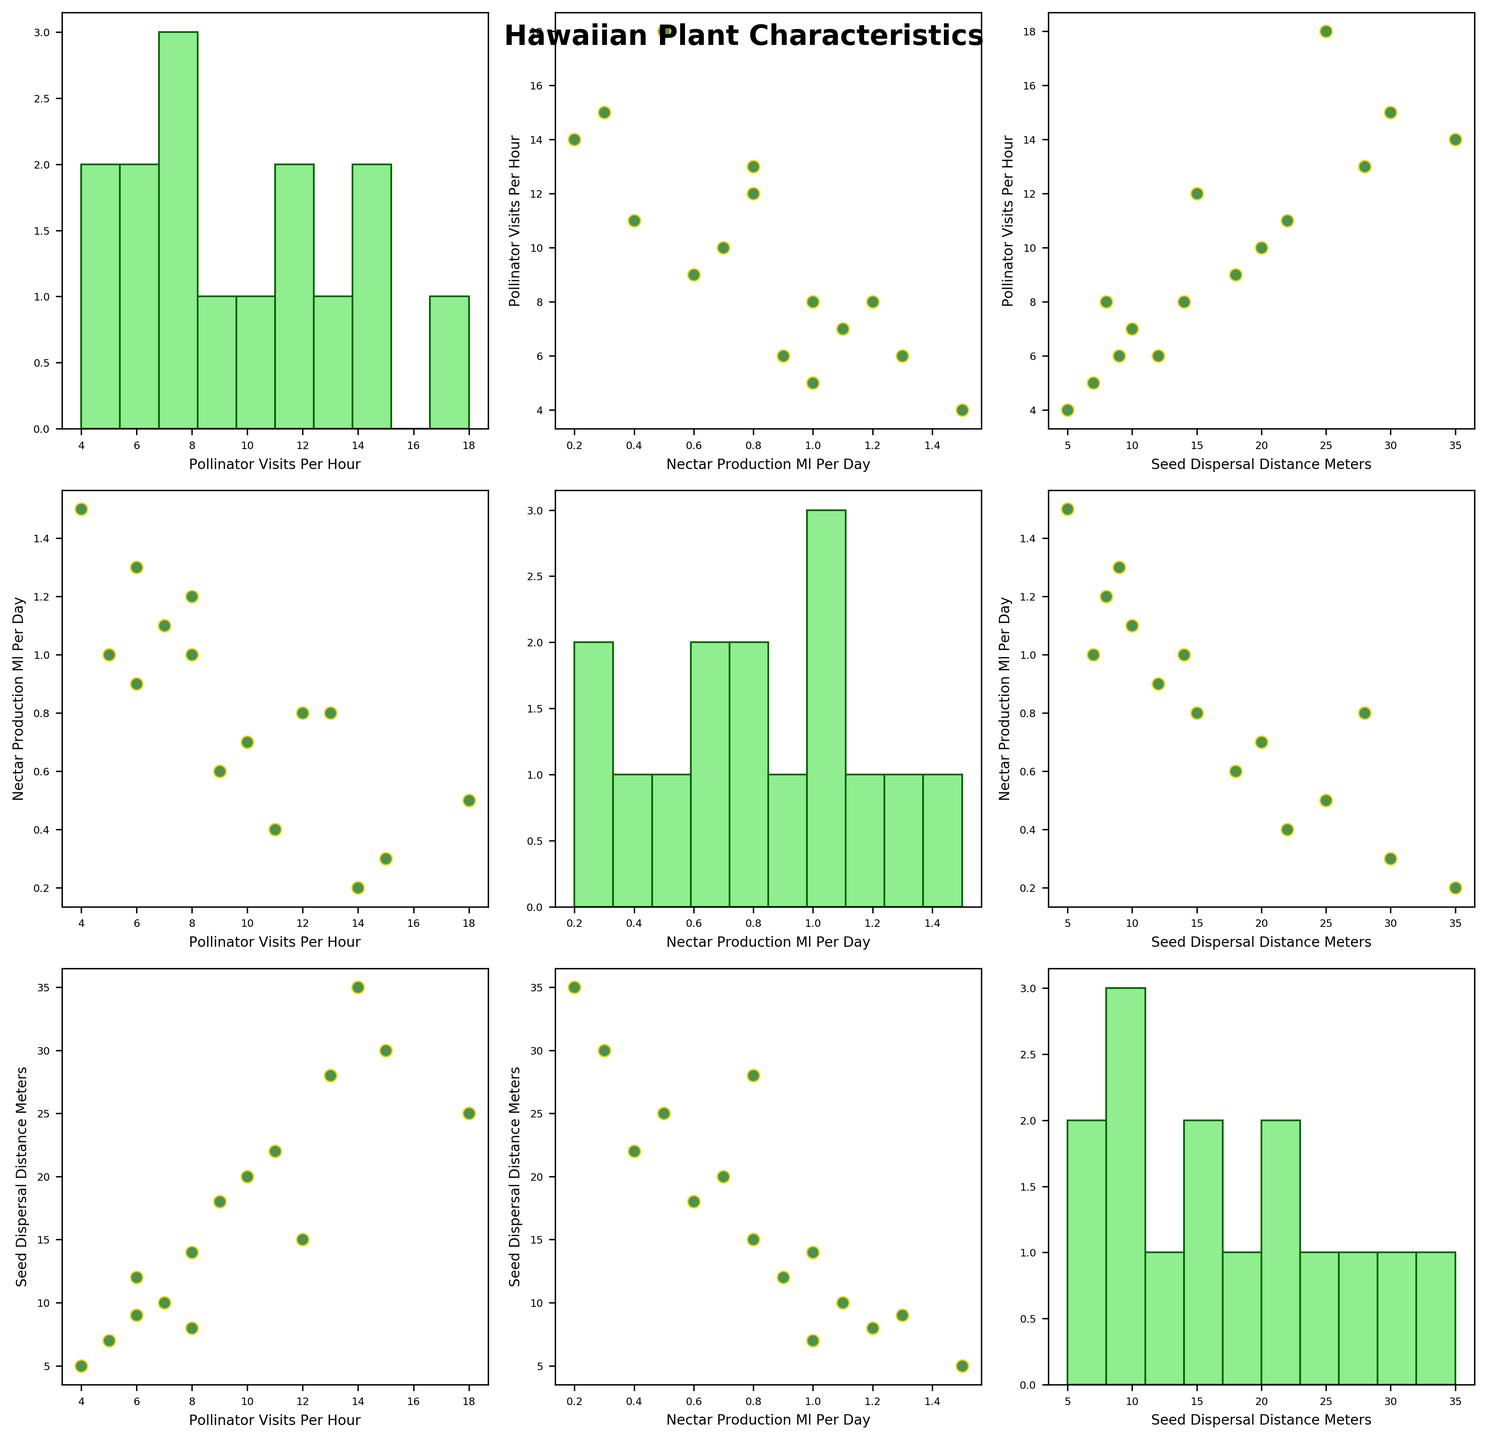Who has the highest nectar production per day? Check the histogram of nectar production. Notice "Brighamia insignis" has the highest value at 1.5 ml/day.
Answer: Brighamia insignis Which plant species has the most frequent pollinator visits? Refer to the histogram of pollinator visits per hour. Observe that "Acacia koa" stands out with 18 visits per hour.
Answer: Acacia koa What is the relationship between nectar production and seed dispersal distance? Look at the scatter plot comparing nectar production and seed dispersal distance. Notice the lack of a clear linear relationship; plants with various nectar productions have diverse dispersal distances.
Answer: No clear relationship Which species has both high pollinator visits and high nectar production? Look at the scatter plot of pollinator visits versus nectar production. Identify "Metrosideros polymorpha" and "Pandanus tectorius" as having high values for both measurements.
Answer: Metrosideros polymorpha, Pandanus tectorius Are there any plants with high seed dispersal distances but low nectar production? Refer to the scatter plot showing nectar production versus seed dispersal distance. Notice that "Bidens hawaiensis" and "Vaccinium reticulatum" fit this description.
Answer: Bidens hawaiensis, Vaccinium reticulatum What is the median pollinator visits per hour? Check the histogram of pollinator visits, line up the data: [4, 5, 6, 6, 7, 8, 8, 9, 10, 11, 12, 13, 14, 15, 18]. The median value is the eighth entry, which is 9.
Answer: 9 Do any plants with similar nectar production have differing seed dispersal distances? Look at species with similar nectar production values (0.8 ml/day). Compare "Metrosideros polymorpha" (15 meters) and "Pandanus tectorius" (28 meters). Notice the significant difference.
Answer: Yes Which plants have seed dispersal distances greater than 20 meters? Check the histogram and scatter plots for seed dispersal distances. "Vaccinium reticulatum," "Pandanus tectorius," and "Bidens hawaiensis" exceed 20 meters.
Answer: Vaccinium reticulatum, Pandanus tectorius, Bidens hawaiensis What is the trend between pollinator visits and seed dispersal distance? Inspect the relevant scatter plot. Note there isn't a strong trend, as both high and low pollinator visit counts correspond to varying dispersal distances.
Answer: No strong trend 